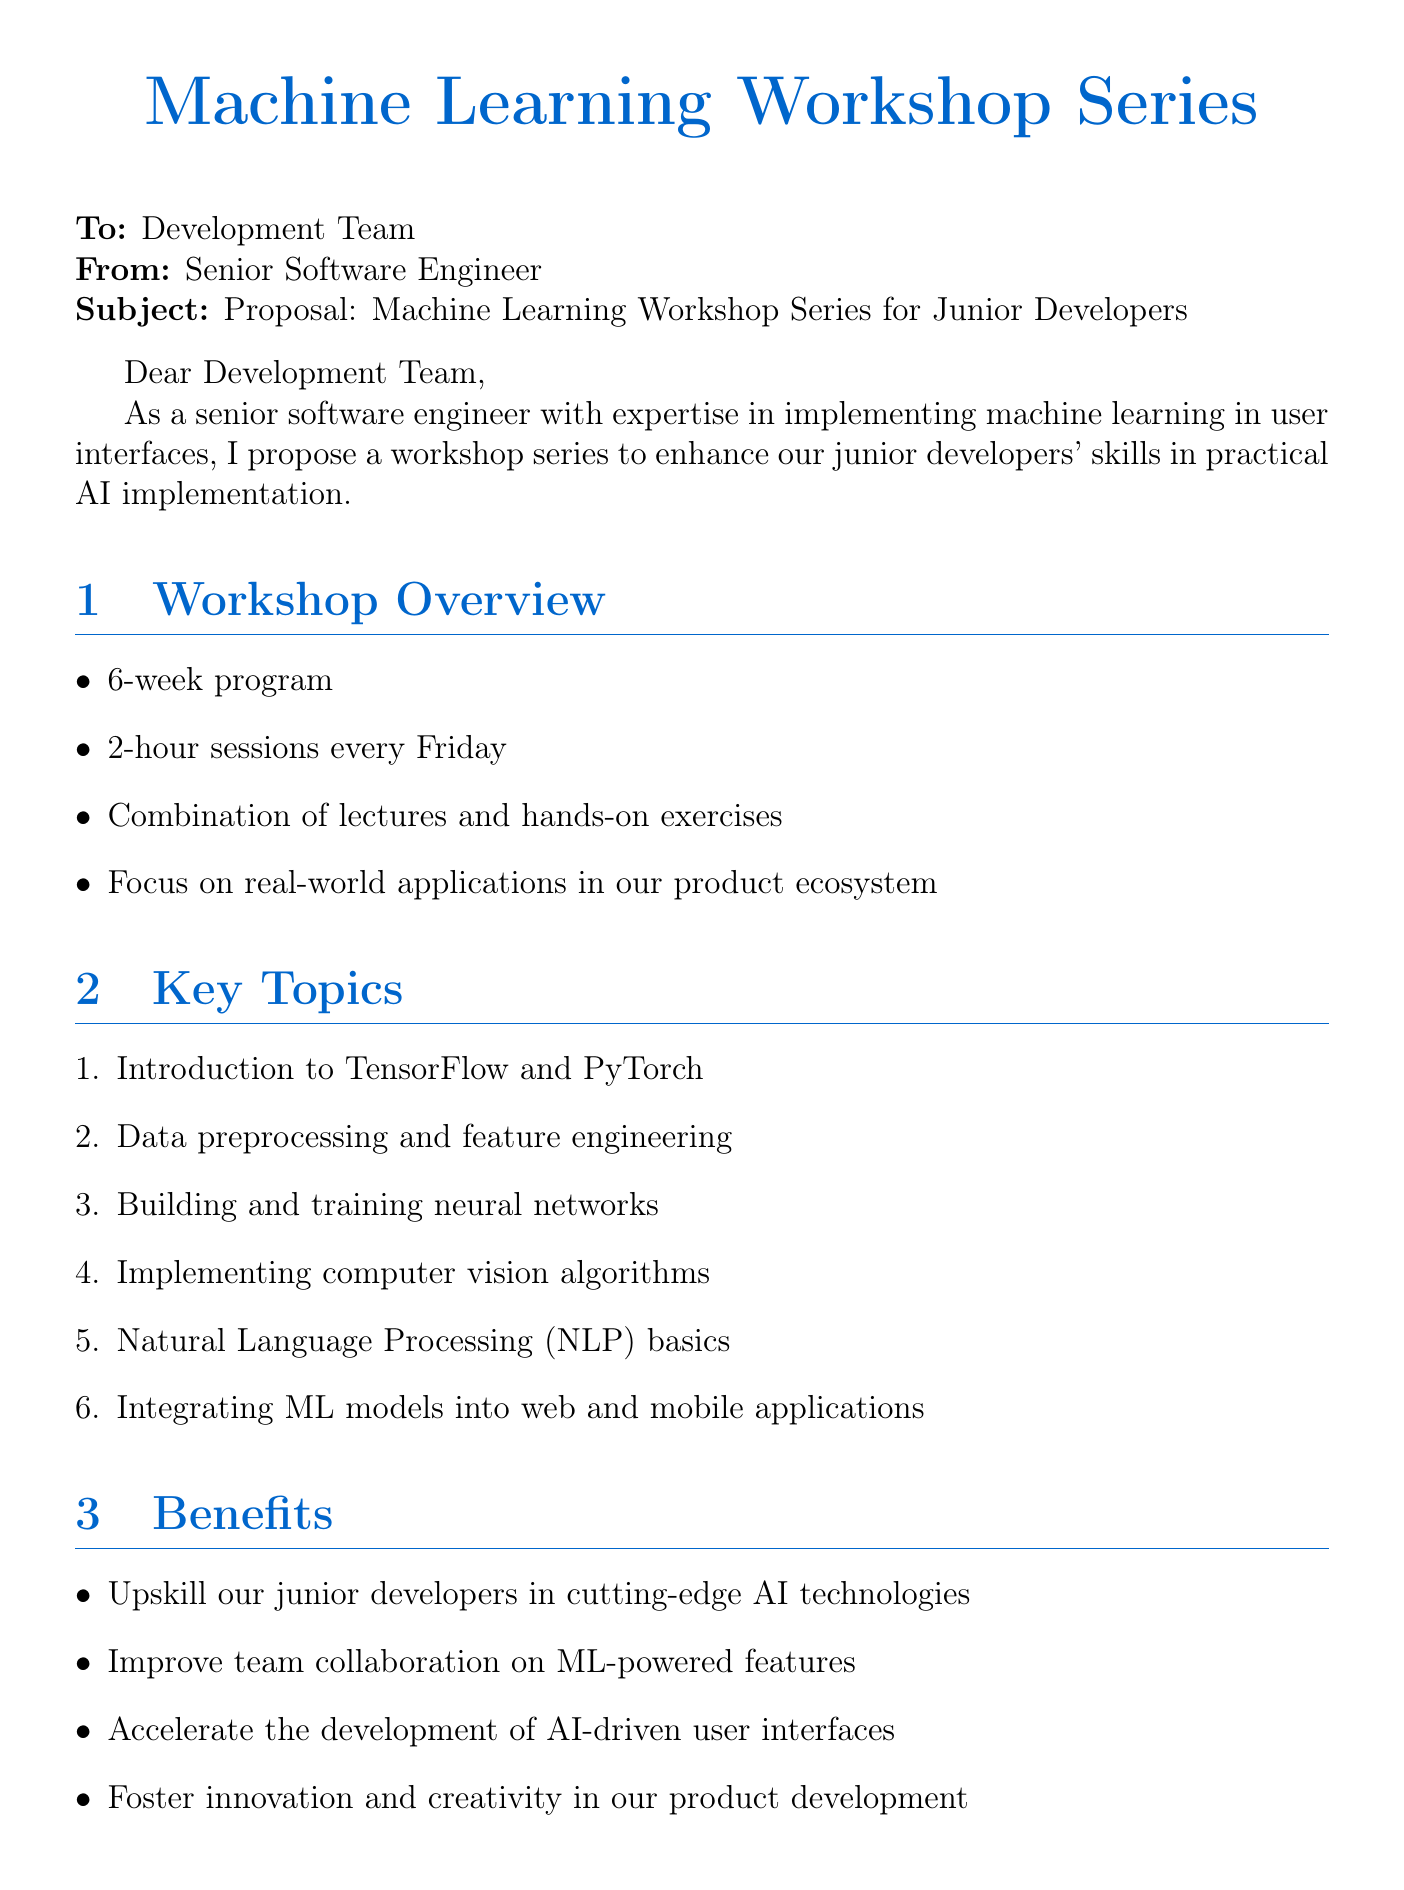What is the duration of the workshop series? The duration of the workshop series is specified as a 6-week program in the document.
Answer: 6-week program How many sessions will there be each week? The document states that there will be 2-hour sessions every Friday, indicating the frequency of sessions per week.
Answer: 2-hour sessions Who is one of the guest speakers mentioned? The document lists Dr. Emily Chen as a guest speaker, making it a specific inquiry about expertise.
Answer: Dr. Emily Chen What is one benefit of the workshop series? The document outlines several benefits and one is to upskill junior developers in cutting-edge AI technologies.
Answer: Upskill junior developers What platform is needed for cloud-based ML training? The document states the need for access to Google Cloud Platform, which is essential for the training sessions.
Answer: Google Cloud Platform What type of exercises will be included in the sessions? The document mentions a combination of lectures and hands-on exercises, expressing the interactive nature of the workshop.
Answer: Hands-on exercises How often will the sessions occur? The schedule indicates that sessions will occur every Friday, which signifies the regularity of the training.
Answer: Every Friday What area does the workshop focus on? The workshop series emphasis is on practical AI implementation relevant to the product ecosystem mentioned in the document.
Answer: Real-world applications in our product ecosystem 